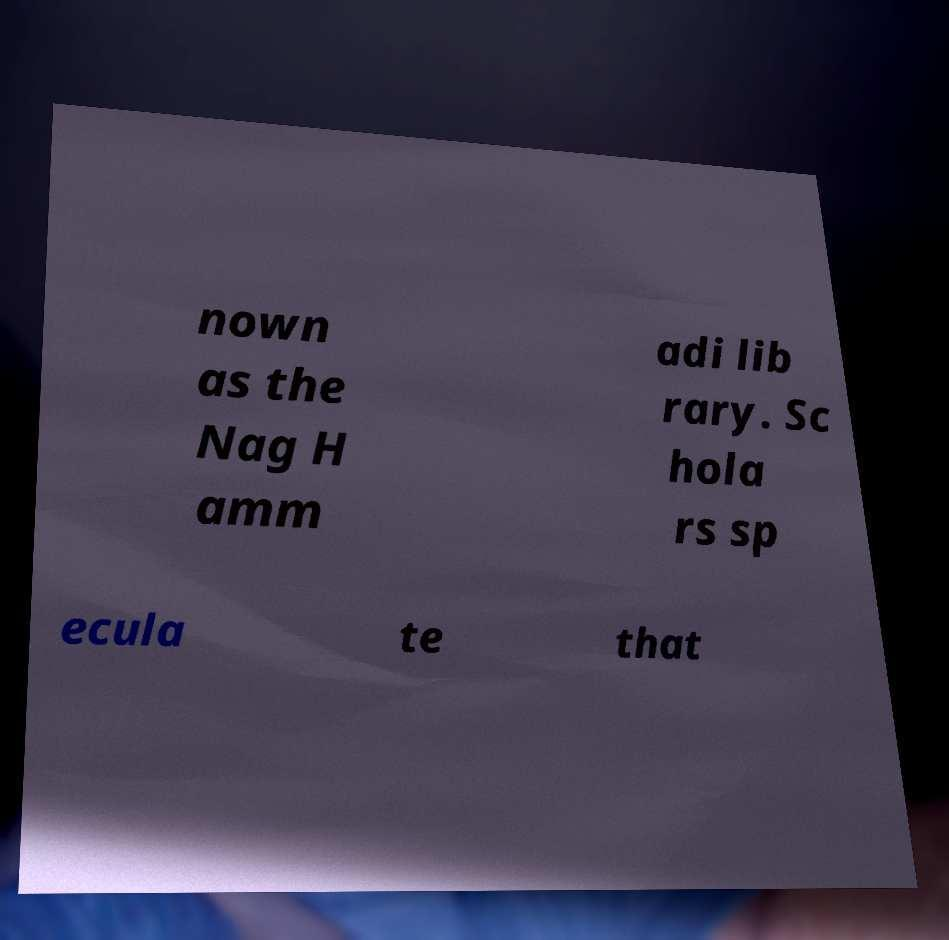For documentation purposes, I need the text within this image transcribed. Could you provide that? nown as the Nag H amm adi lib rary. Sc hola rs sp ecula te that 